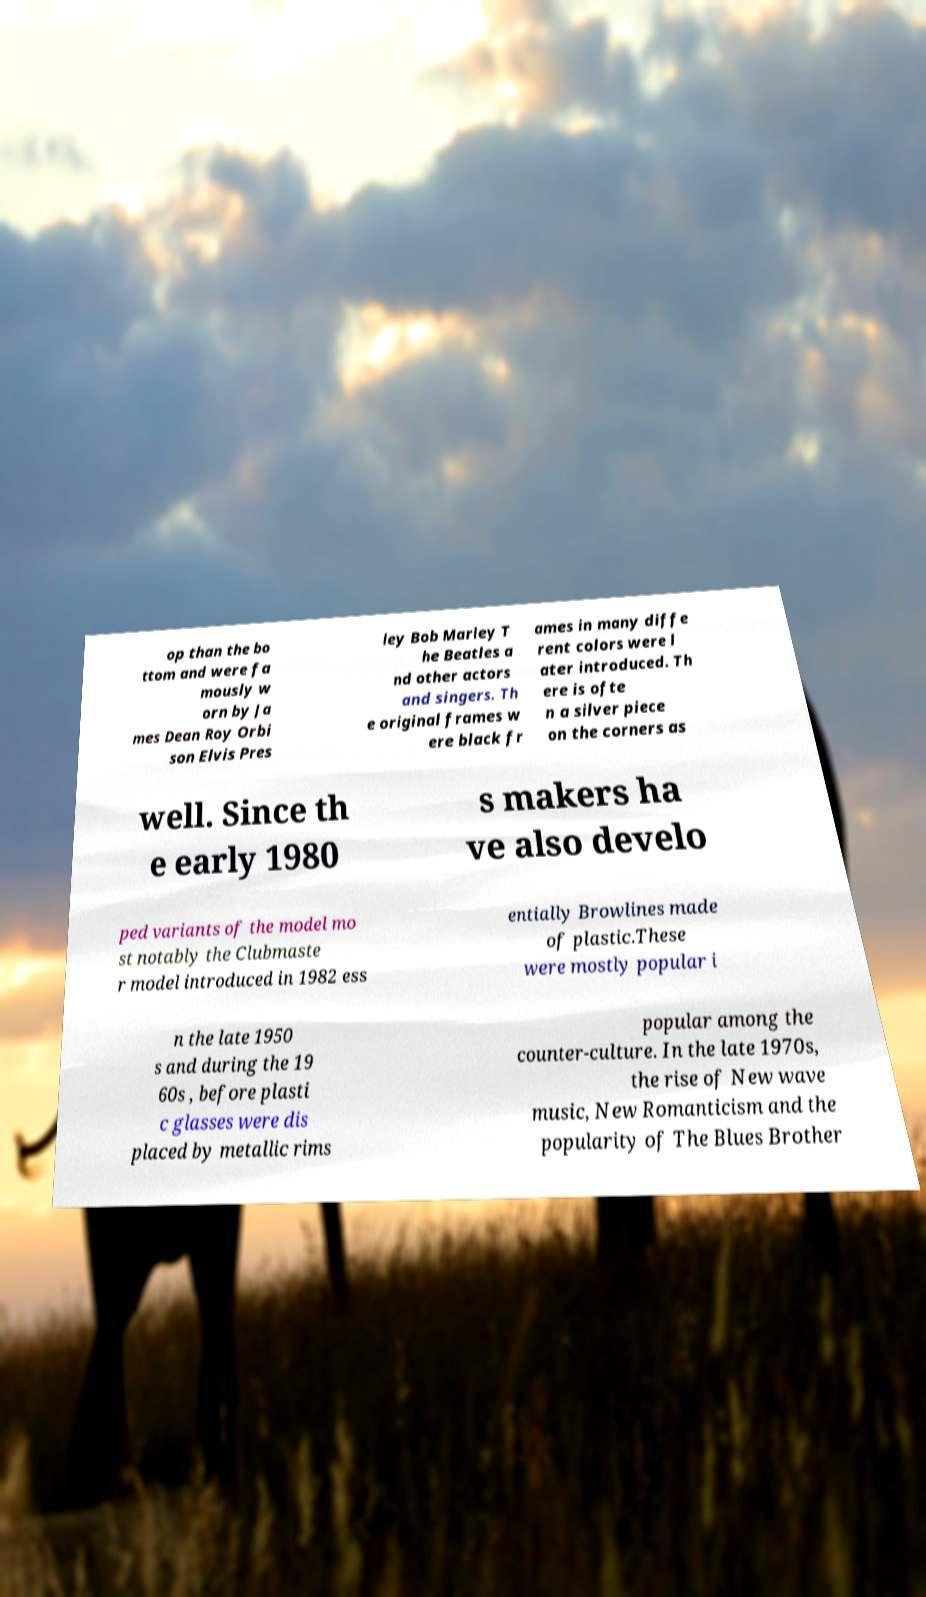Could you assist in decoding the text presented in this image and type it out clearly? op than the bo ttom and were fa mously w orn by Ja mes Dean Roy Orbi son Elvis Pres ley Bob Marley T he Beatles a nd other actors and singers. Th e original frames w ere black fr ames in many diffe rent colors were l ater introduced. Th ere is ofte n a silver piece on the corners as well. Since th e early 1980 s makers ha ve also develo ped variants of the model mo st notably the Clubmaste r model introduced in 1982 ess entially Browlines made of plastic.These were mostly popular i n the late 1950 s and during the 19 60s , before plasti c glasses were dis placed by metallic rims popular among the counter-culture. In the late 1970s, the rise of New wave music, New Romanticism and the popularity of The Blues Brother 